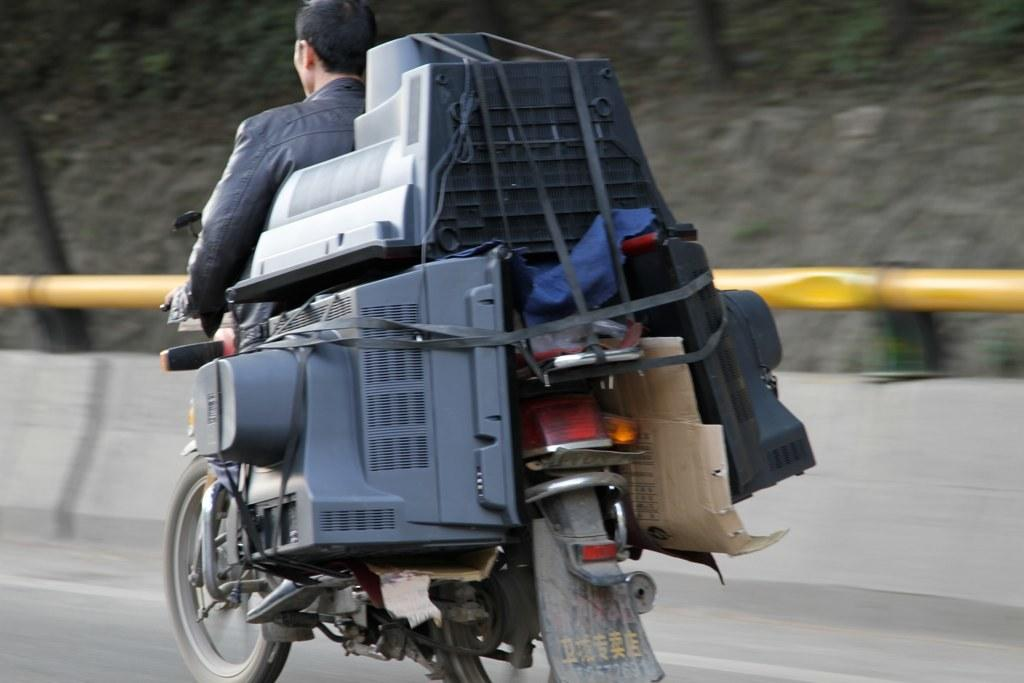What is the person in the image doing? There is a person riding a motor vehicle on the road in the image. What electronic devices can be seen in the image? There are TVs in the image. What is attached to the wall in the image? There is a cardboard sheet attached to the wall in the image. What type of object is present on the ground in the image? There is a stone in the image. What type of liquid is being spilled in the image? There is no liquid being spilled in the image; it only features a person riding a motor vehicle, TVs, a cardboard sheet, and a stone. 